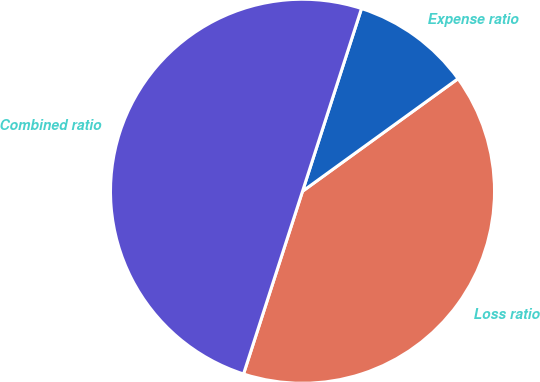Convert chart to OTSL. <chart><loc_0><loc_0><loc_500><loc_500><pie_chart><fcel>Loss ratio<fcel>Expense ratio<fcel>Combined ratio<nl><fcel>39.94%<fcel>10.06%<fcel>50.0%<nl></chart> 